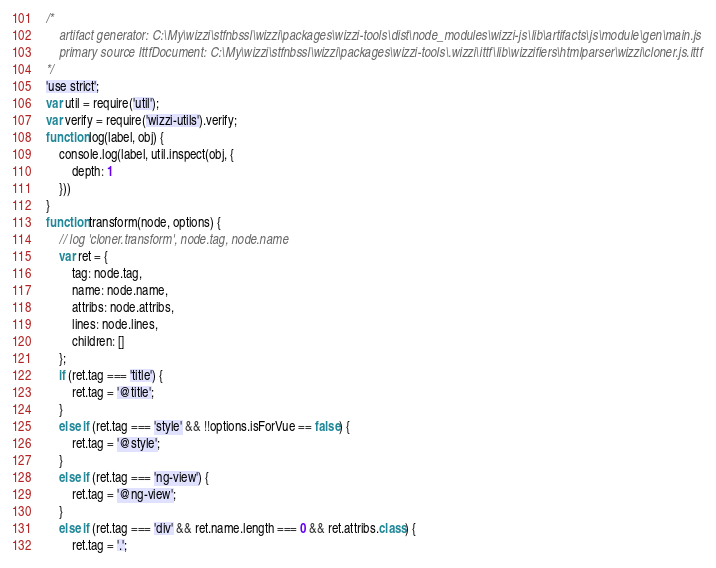Convert code to text. <code><loc_0><loc_0><loc_500><loc_500><_JavaScript_>/*
    artifact generator: C:\My\wizzi\stfnbssl\wizzi\packages\wizzi-tools\dist\node_modules\wizzi-js\lib\artifacts\js\module\gen\main.js
    primary source IttfDocument: C:\My\wizzi\stfnbssl\wizzi\packages\wizzi-tools\.wizzi\ittf\lib\wizzifiers\htmlparser\wizzi\cloner.js.ittf
*/
'use strict';
var util = require('util');
var verify = require('wizzi-utils').verify;
function log(label, obj) {
    console.log(label, util.inspect(obj, {
        depth: 1
    }))
}
function transform(node, options) {
    // log 'cloner.transform', node.tag, node.name
    var ret = {
        tag: node.tag, 
        name: node.name, 
        attribs: node.attribs, 
        lines: node.lines, 
        children: []
    };
    if (ret.tag === 'title') {
        ret.tag = '@title';
    }
    else if (ret.tag === 'style' && !!options.isForVue == false) {
        ret.tag = '@style';
    }
    else if (ret.tag === 'ng-view') {
        ret.tag = '@ng-view';
    }
    else if (ret.tag === 'div' && ret.name.length === 0 && ret.attribs.class) {
        ret.tag = '.';</code> 